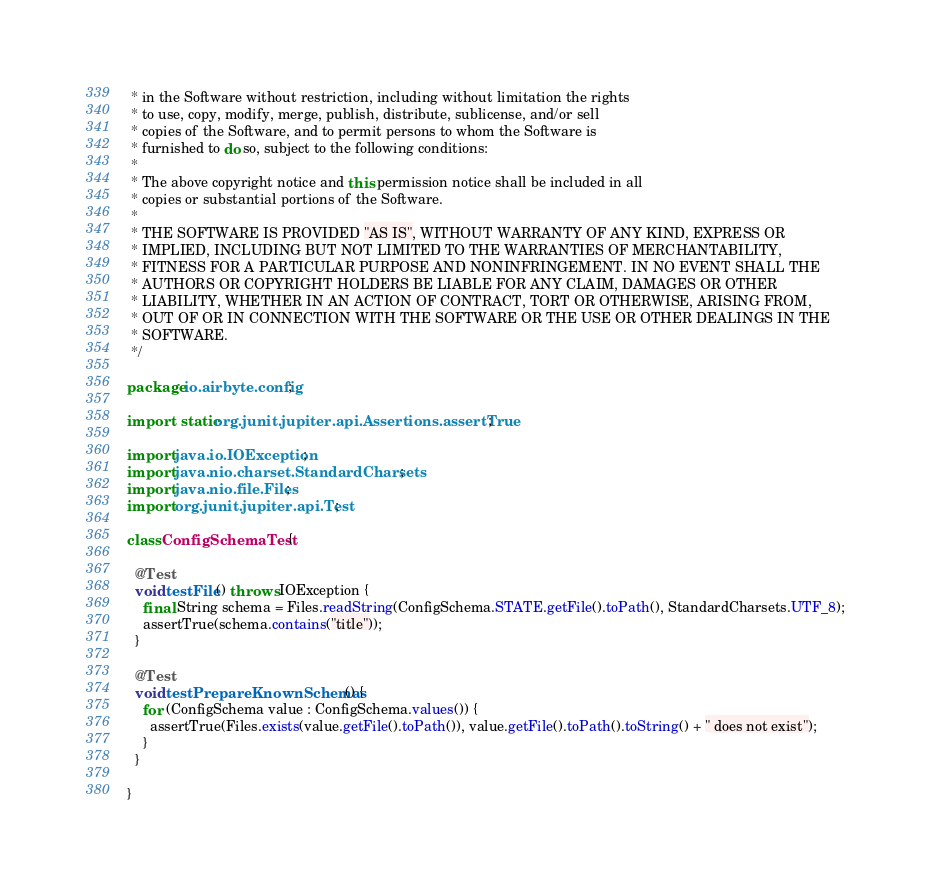<code> <loc_0><loc_0><loc_500><loc_500><_Java_> * in the Software without restriction, including without limitation the rights
 * to use, copy, modify, merge, publish, distribute, sublicense, and/or sell
 * copies of the Software, and to permit persons to whom the Software is
 * furnished to do so, subject to the following conditions:
 *
 * The above copyright notice and this permission notice shall be included in all
 * copies or substantial portions of the Software.
 *
 * THE SOFTWARE IS PROVIDED "AS IS", WITHOUT WARRANTY OF ANY KIND, EXPRESS OR
 * IMPLIED, INCLUDING BUT NOT LIMITED TO THE WARRANTIES OF MERCHANTABILITY,
 * FITNESS FOR A PARTICULAR PURPOSE AND NONINFRINGEMENT. IN NO EVENT SHALL THE
 * AUTHORS OR COPYRIGHT HOLDERS BE LIABLE FOR ANY CLAIM, DAMAGES OR OTHER
 * LIABILITY, WHETHER IN AN ACTION OF CONTRACT, TORT OR OTHERWISE, ARISING FROM,
 * OUT OF OR IN CONNECTION WITH THE SOFTWARE OR THE USE OR OTHER DEALINGS IN THE
 * SOFTWARE.
 */

package io.airbyte.config;

import static org.junit.jupiter.api.Assertions.assertTrue;

import java.io.IOException;
import java.nio.charset.StandardCharsets;
import java.nio.file.Files;
import org.junit.jupiter.api.Test;

class ConfigSchemaTest {

  @Test
  void testFile() throws IOException {
    final String schema = Files.readString(ConfigSchema.STATE.getFile().toPath(), StandardCharsets.UTF_8);
    assertTrue(schema.contains("title"));
  }

  @Test
  void testPrepareKnownSchemas() {
    for (ConfigSchema value : ConfigSchema.values()) {
      assertTrue(Files.exists(value.getFile().toPath()), value.getFile().toPath().toString() + " does not exist");
    }
  }

}
</code> 